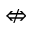Convert formula to latex. <formula><loc_0><loc_0><loc_500><loc_500>\ n L e f t r i g h t a r r o w</formula> 